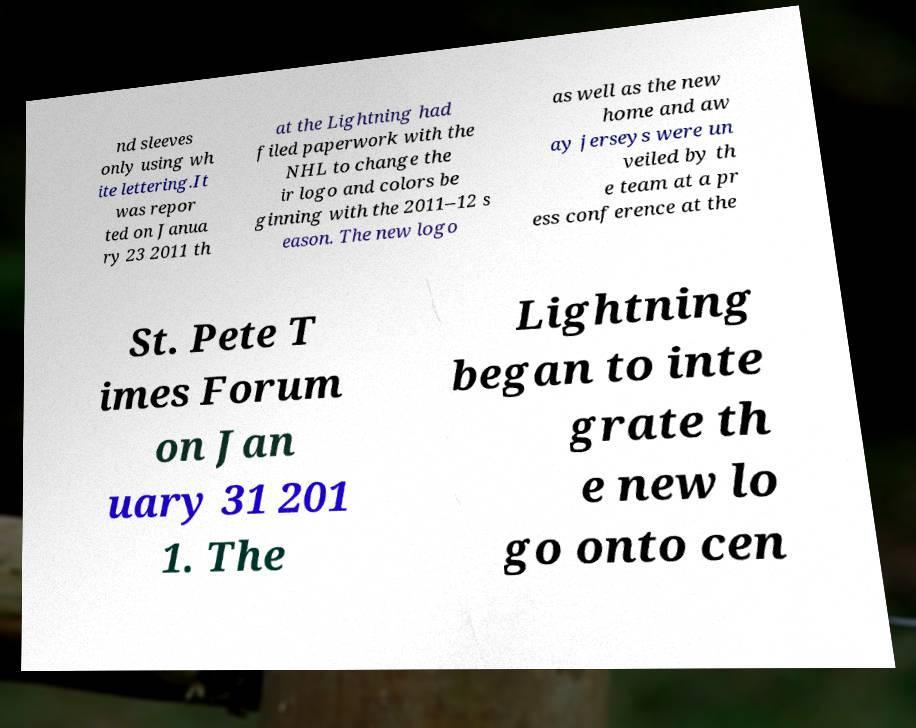For documentation purposes, I need the text within this image transcribed. Could you provide that? nd sleeves only using wh ite lettering.It was repor ted on Janua ry 23 2011 th at the Lightning had filed paperwork with the NHL to change the ir logo and colors be ginning with the 2011–12 s eason. The new logo as well as the new home and aw ay jerseys were un veiled by th e team at a pr ess conference at the St. Pete T imes Forum on Jan uary 31 201 1. The Lightning began to inte grate th e new lo go onto cen 